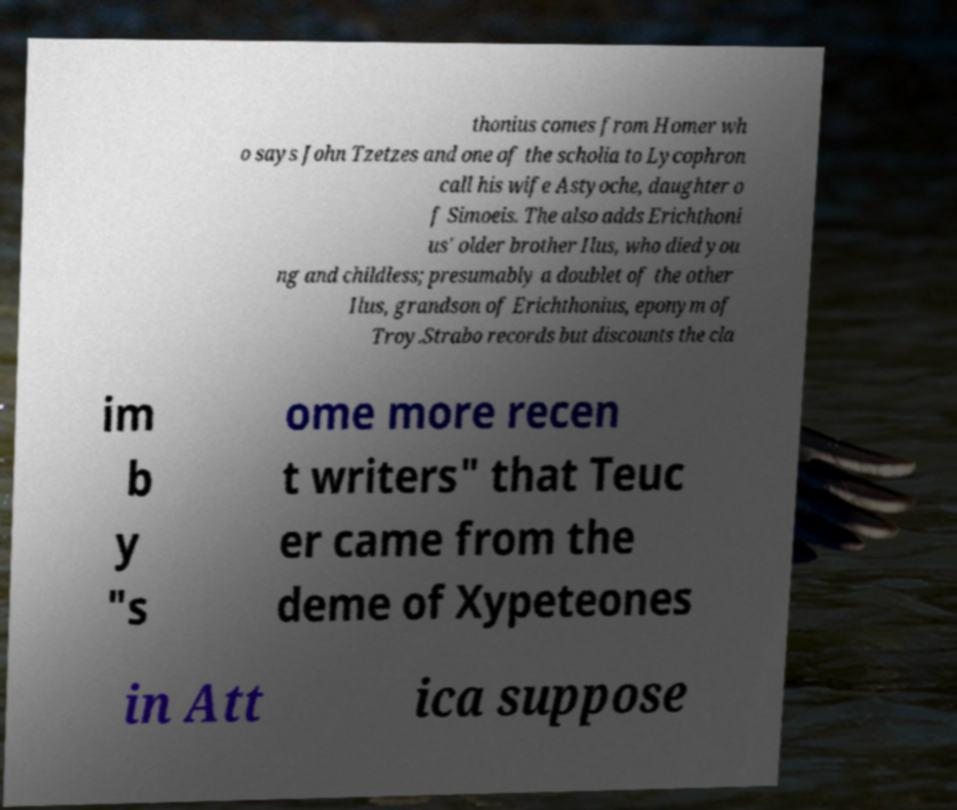Please identify and transcribe the text found in this image. thonius comes from Homer wh o says John Tzetzes and one of the scholia to Lycophron call his wife Astyoche, daughter o f Simoeis. The also adds Erichthoni us' older brother Ilus, who died you ng and childless; presumably a doublet of the other Ilus, grandson of Erichthonius, eponym of Troy.Strabo records but discounts the cla im b y "s ome more recen t writers" that Teuc er came from the deme of Xypeteones in Att ica suppose 